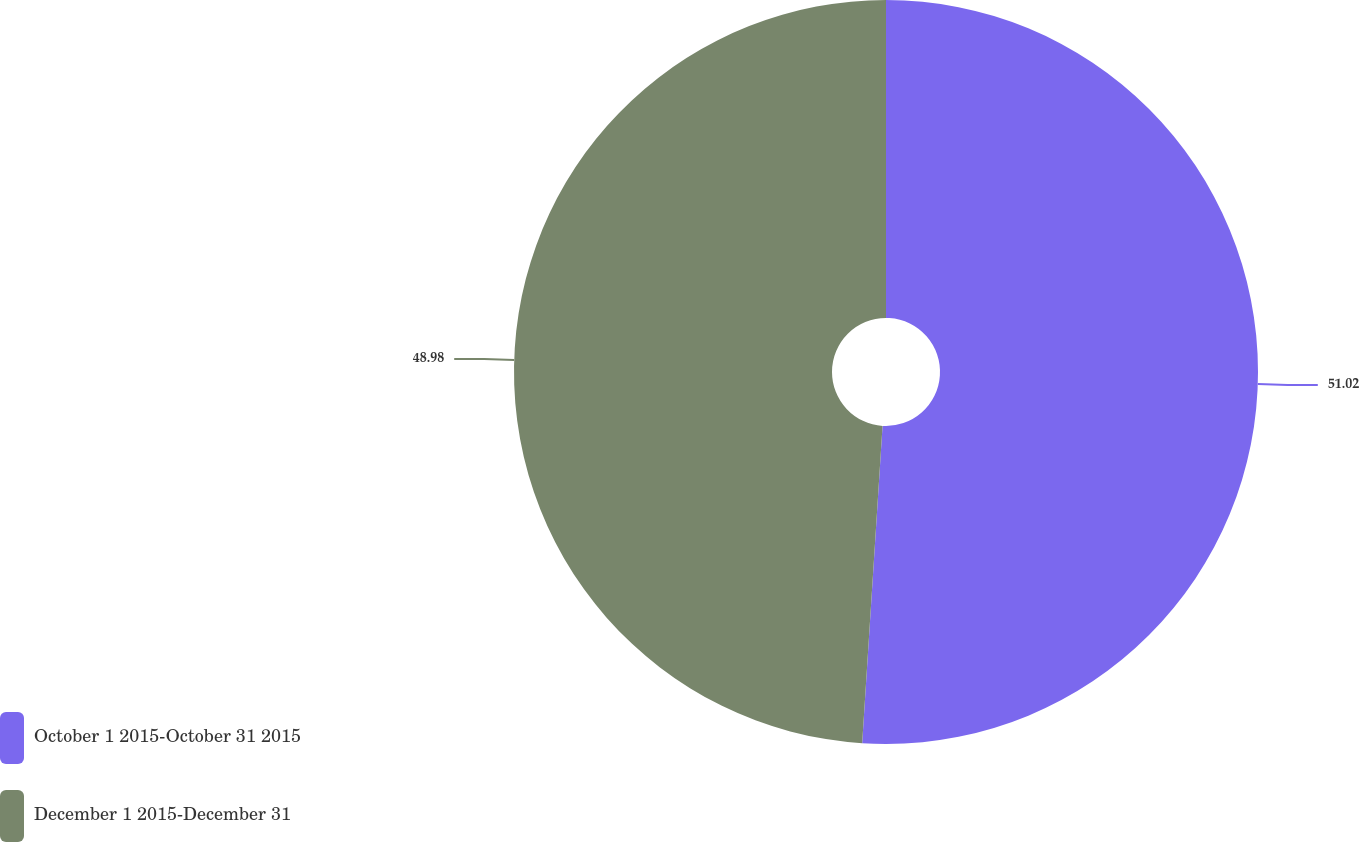<chart> <loc_0><loc_0><loc_500><loc_500><pie_chart><fcel>October 1 2015-October 31 2015<fcel>December 1 2015-December 31<nl><fcel>51.02%<fcel>48.98%<nl></chart> 